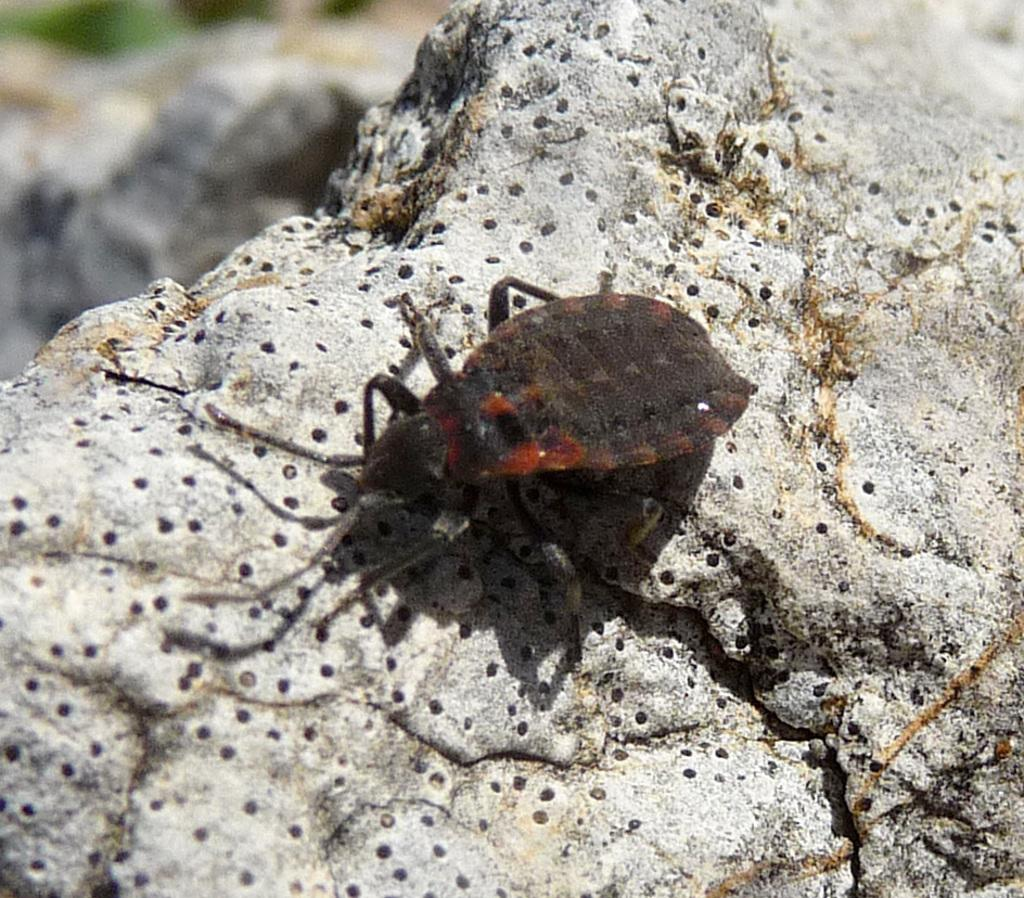What is the main subject of the image? The main subject of the image is a bug. Where is the bug located in the image? The bug is on a rock in the image. Can you describe the position of the bug in the image? The bug is in the center of the image. What type of sound does the key make when it is used in a game of chess in the image? There is no key or game of chess present in the image, so it is not possible to determine what sound it might make. 